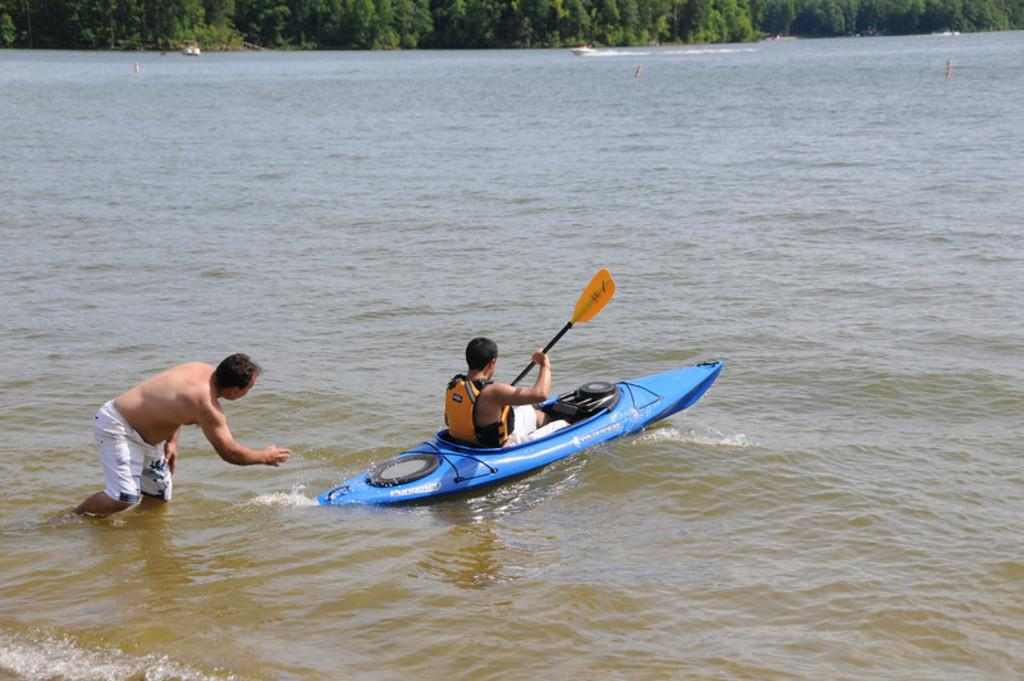What body of water is present in the image? There is a river in the image. What activity is taking place on the river? A man is selling on a boat in the river. What is the other man in the image doing? Another man is standing in the river. What can be seen in the distance in the image? There are trees in the background of the image. How many friends does the man selling on the boat have in the image? There is no information about friends in the image; it only shows a man selling on a boat and another man standing in the river. 